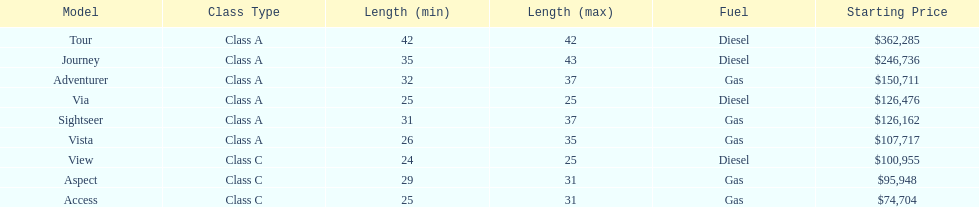Which model had the highest starting price Tour. 